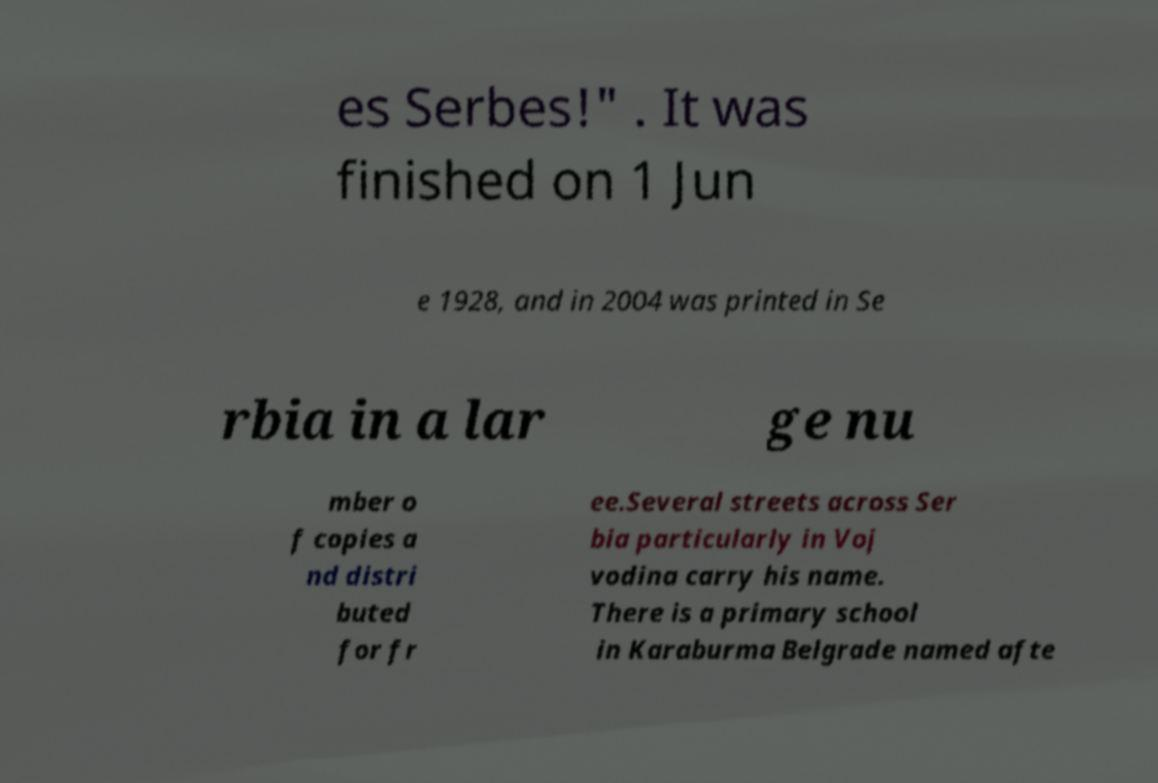Please identify and transcribe the text found in this image. es Serbes!" . It was finished on 1 Jun e 1928, and in 2004 was printed in Se rbia in a lar ge nu mber o f copies a nd distri buted for fr ee.Several streets across Ser bia particularly in Voj vodina carry his name. There is a primary school in Karaburma Belgrade named afte 